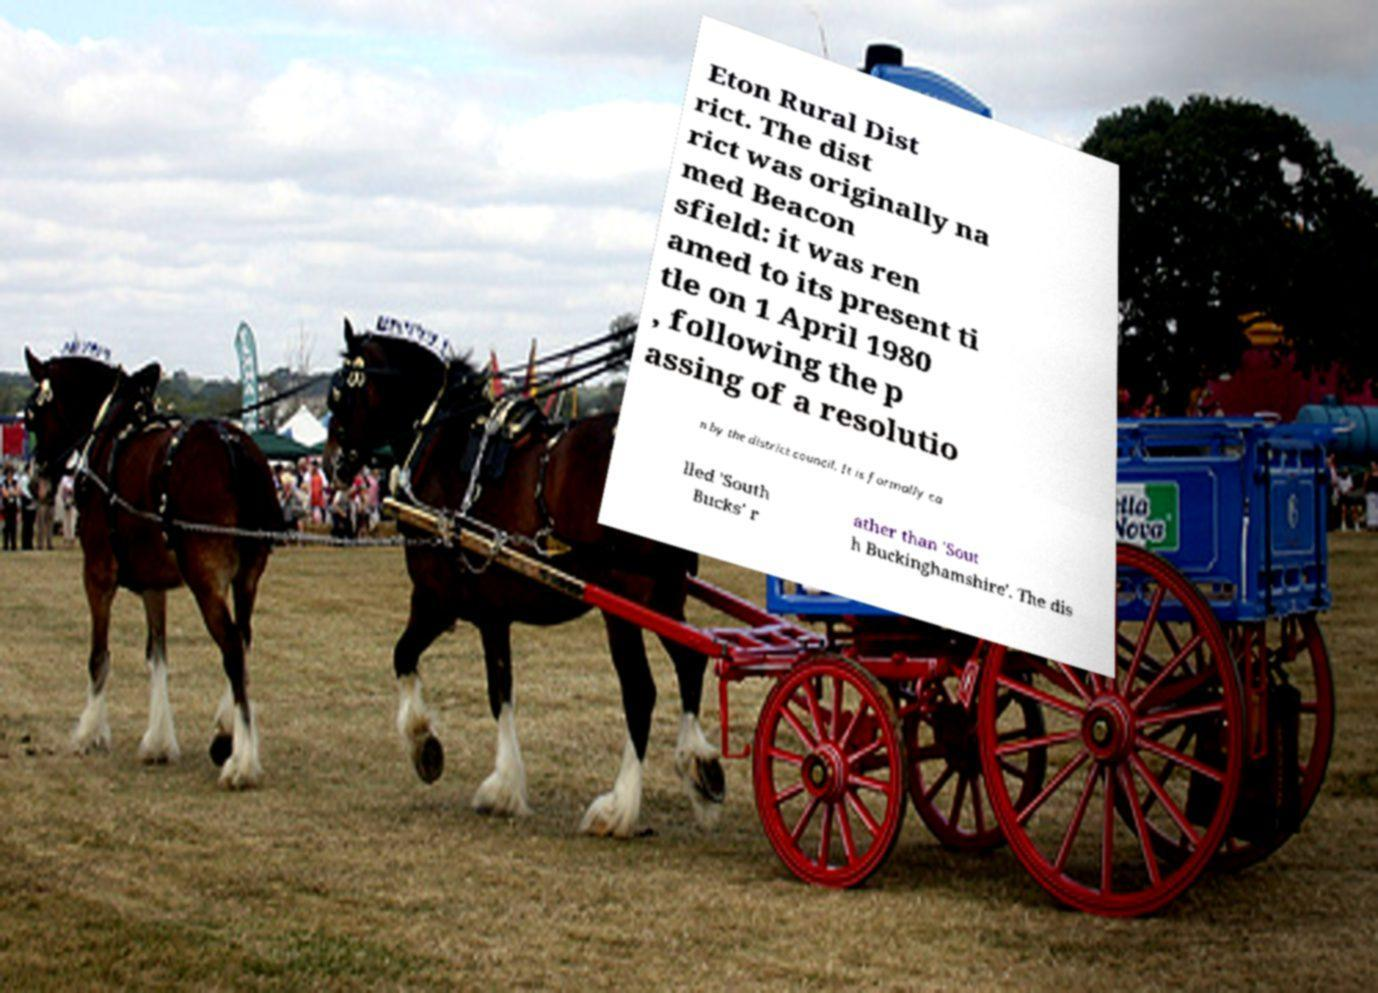Can you accurately transcribe the text from the provided image for me? Eton Rural Dist rict. The dist rict was originally na med Beacon sfield: it was ren amed to its present ti tle on 1 April 1980 , following the p assing of a resolutio n by the district council. It is formally ca lled 'South Bucks' r ather than 'Sout h Buckinghamshire'. The dis 